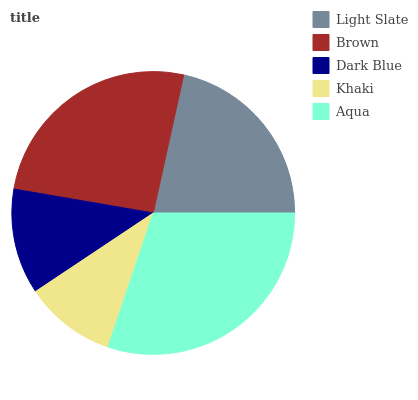Is Khaki the minimum?
Answer yes or no. Yes. Is Aqua the maximum?
Answer yes or no. Yes. Is Brown the minimum?
Answer yes or no. No. Is Brown the maximum?
Answer yes or no. No. Is Brown greater than Light Slate?
Answer yes or no. Yes. Is Light Slate less than Brown?
Answer yes or no. Yes. Is Light Slate greater than Brown?
Answer yes or no. No. Is Brown less than Light Slate?
Answer yes or no. No. Is Light Slate the high median?
Answer yes or no. Yes. Is Light Slate the low median?
Answer yes or no. Yes. Is Dark Blue the high median?
Answer yes or no. No. Is Khaki the low median?
Answer yes or no. No. 